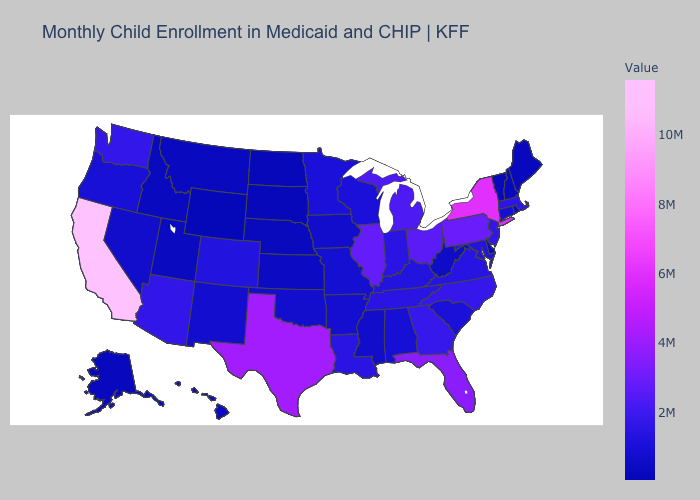Does Wyoming have the lowest value in the USA?
Concise answer only. Yes. Does Wyoming have the lowest value in the USA?
Give a very brief answer. Yes. Does Wyoming have the lowest value in the USA?
Be succinct. Yes. 